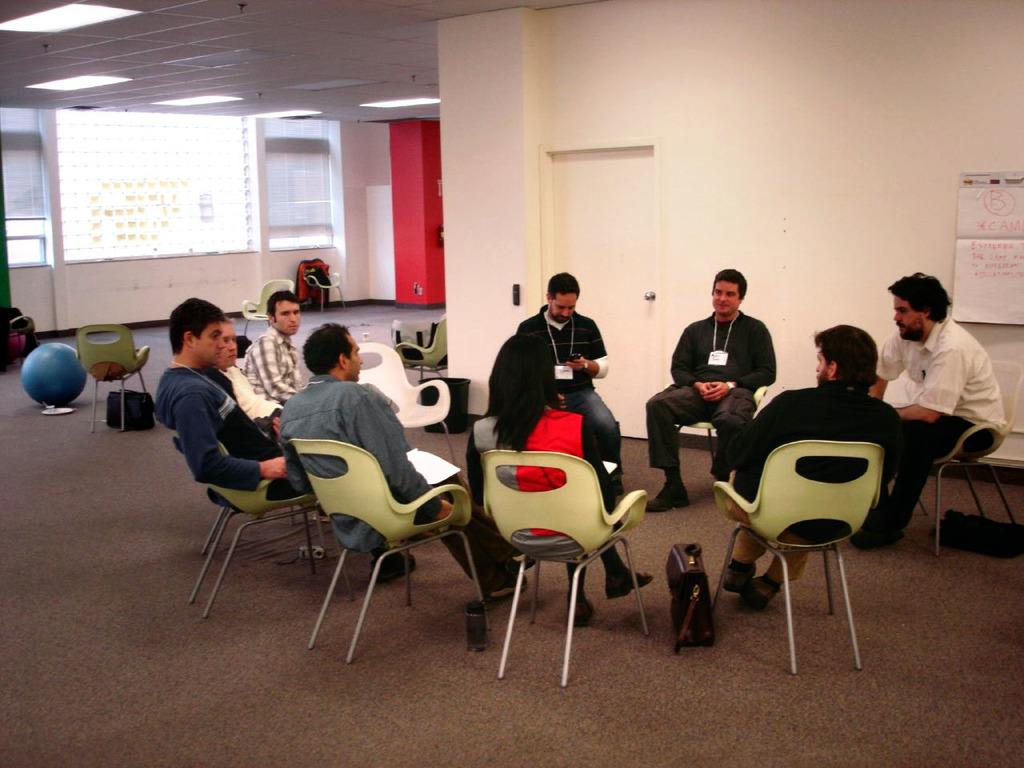How many people are in the image? There is a group of persons in the image. What are the persons doing in the image? The persons are sitting on chairs. Where are the chairs located? The chairs are in a room. What is on the left side of the image? There is a projector screen on the left side of the image. Can you see any clouds in the image? There are no clouds visible in the image, as it is an indoor scene with a group of persons sitting on chairs in a room. 